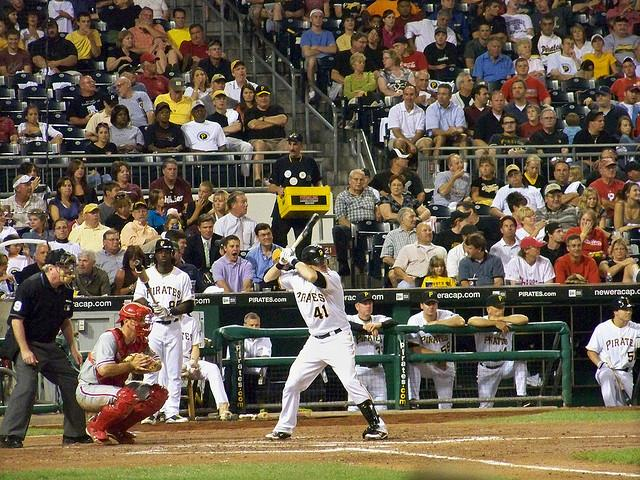What number is the batter wearing? 41 